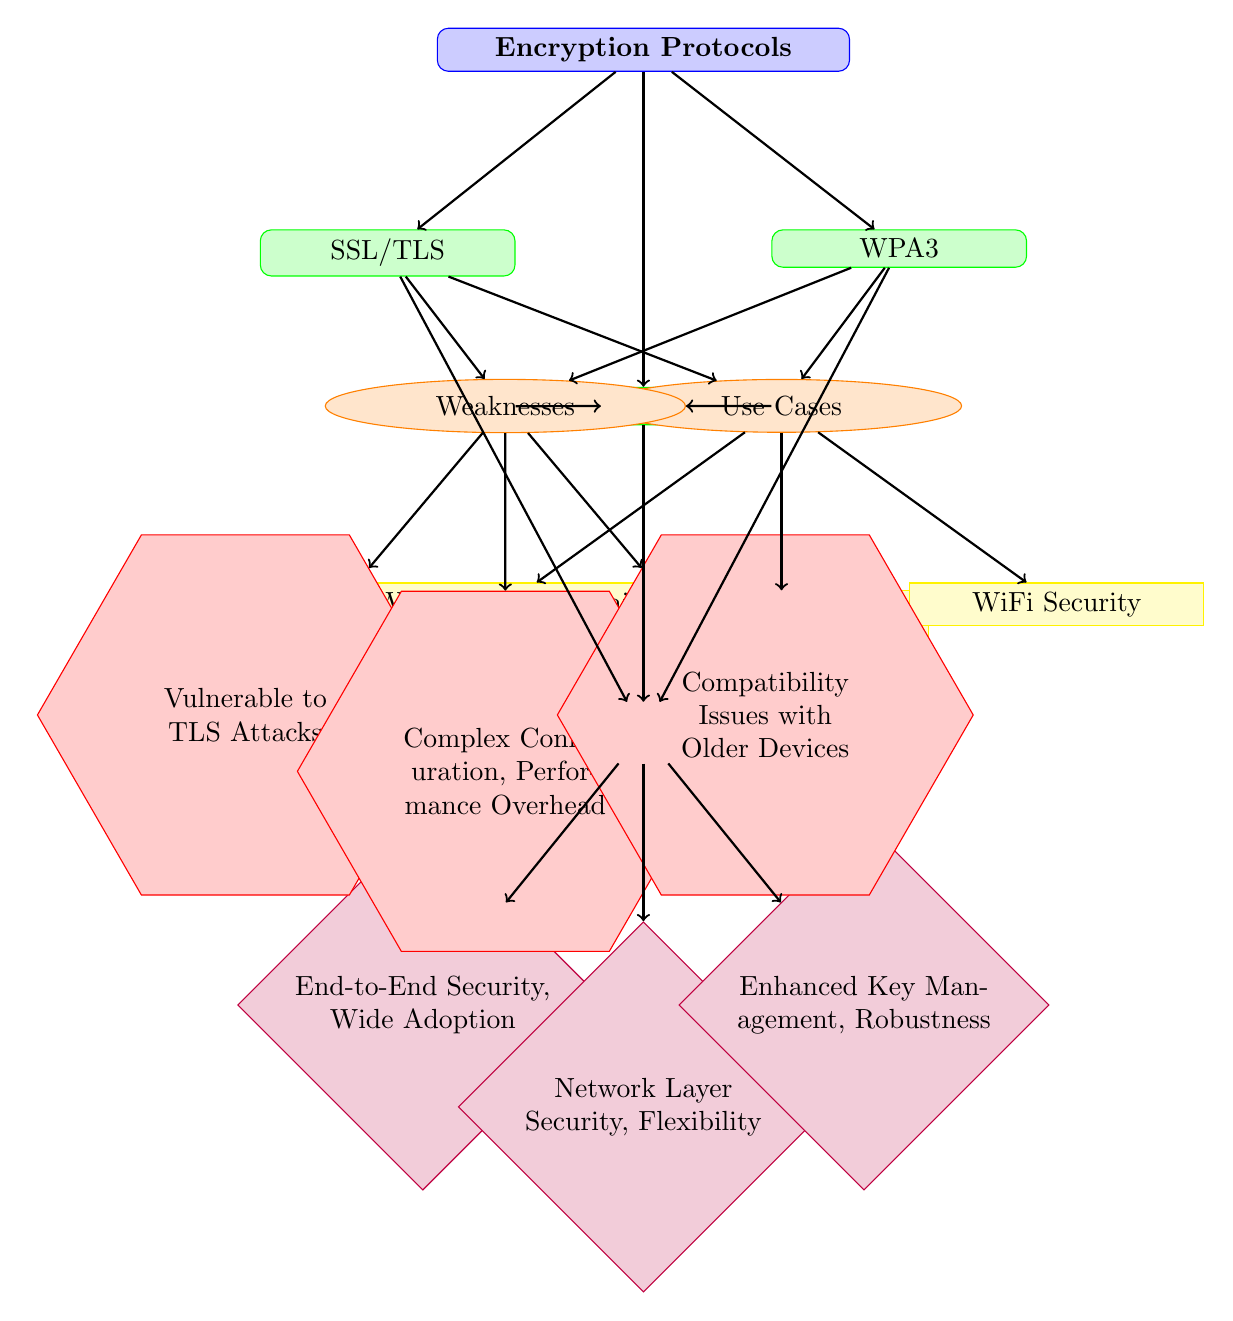What's the first encryption protocol listed in the diagram? The first protocol shown in the diagram, below the root node "Encryption Protocols," is SSL/TLS. It is positioned at the left side compared to the other protocols.
Answer: SSL/TLS How many weaknesses are listed for each protocol? Each protocol has one corresponding weakness listed in the diagram. Therefore, the total number of weaknesses is three, one for each protocol (SSL/TLS, IPsec, and WPA3).
Answer: One What use cases are associated with IPsec? The specific use cases associated with IPsec are displayed in the diagram as "VPN" and "Secure Networks," connected directly below the IPsec node.
Answer: VPN, Secure Networks Which encryption protocol is described as having "Enhanced Key Management"? The protocol that has "Enhanced Key Management" as a strength is WPA3. This strength is connected below the WPA3 protocol node in the diagram.
Answer: WPA3 What is the strength associated with SSL/TLS? The strength associated with SSL/TLS is noted as "End-to-End Security, Wide Adoption" in the diagram. This detail is found below the SSL/TLS protocol node.
Answer: End-to-End Security, Wide Adoption Which protocol's weakness is described as "Complex Configuration, Performance Overhead"? This description belongs to the IPsec protocol, as seen in the weaknesses section of the diagram where it specifies its vulnerabilities.
Answer: IPsec What can be said about the use cases of SSL/TLS in comparison to WPA3? SSL/TLS is associated with use cases including "Web Browsing" and "Email," while WPA3 is linked to "WiFi Security." Thus, SSL/TLS has a broader application range in online services compared to WPA3, which is specific to wireless security.
Answer: SSL/TLS has broader use cases Which protocol shows compatibility issues with older devices as a weakness? The protocol that indicates this weakness is WPA3 in the diagram. The weakness concerning compatibility issues is explicitly stated below the WPA3 node in the weaknesses section.
Answer: WPA3 How many encryption protocols are compared in the diagram? The diagram compares a total of three encryption protocols: SSL/TLS, IPsec, and WPA3, as represented under the "Encryption Protocols" root node.
Answer: Three 